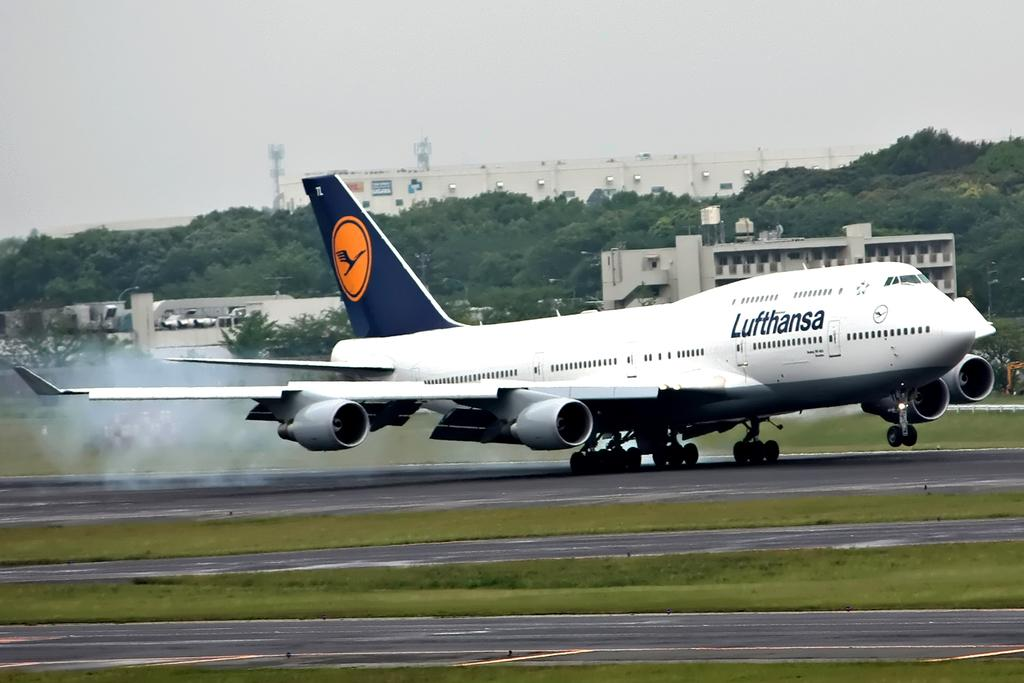What is the main subject of the image? The main subject of the image is an airplane. Where is the airplane located in the image? The airplane is on the ground in the image. What can be seen in the background of the image? There are buildings, trees, and the sky visible in the background of the image. What type of home can be seen in the image? There is no home present in the image; it features an airplane on the ground with buildings, trees, and the sky visible in the background. Can you tell me how many halls are in the image? There is no hall present in the image; it features an airplane on the ground with buildings, trees, and the sky visible in the background. 